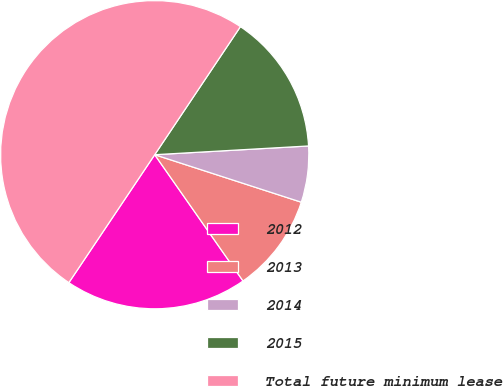Convert chart to OTSL. <chart><loc_0><loc_0><loc_500><loc_500><pie_chart><fcel>2012<fcel>2013<fcel>2014<fcel>2015<fcel>Total future minimum lease<nl><fcel>19.12%<fcel>10.3%<fcel>5.89%<fcel>14.71%<fcel>49.98%<nl></chart> 